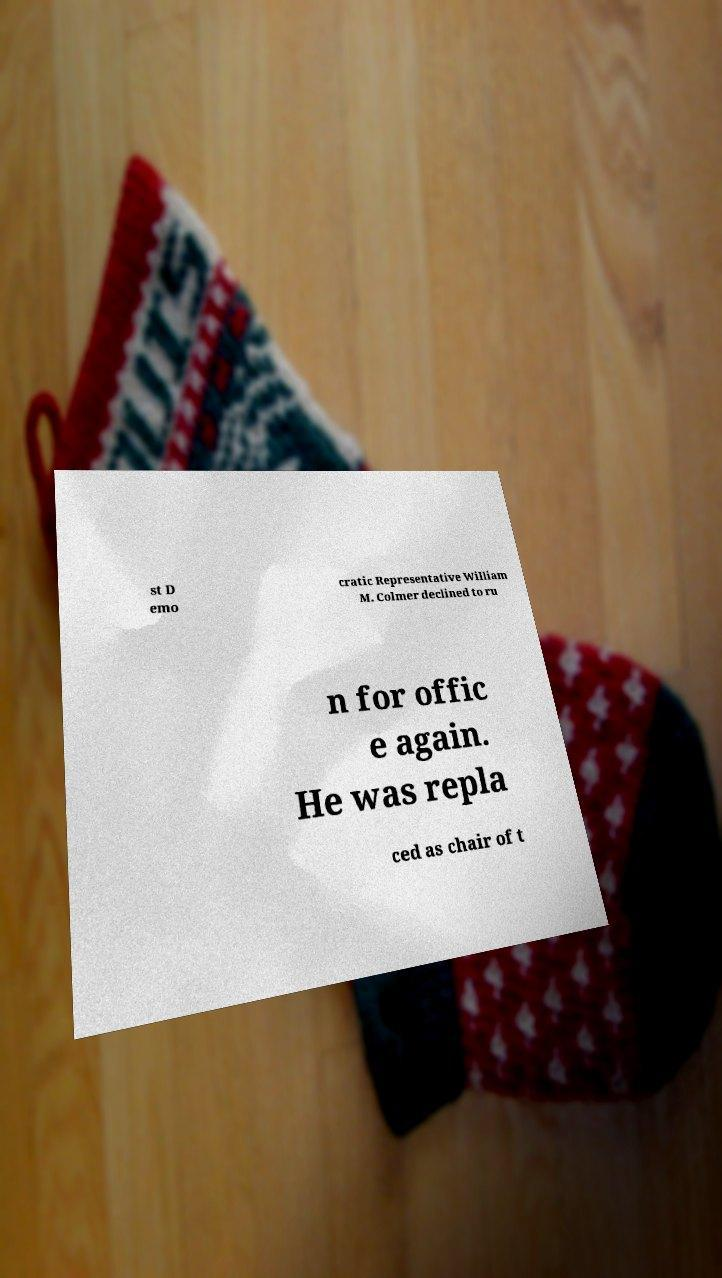Can you accurately transcribe the text from the provided image for me? st D emo cratic Representative William M. Colmer declined to ru n for offic e again. He was repla ced as chair of t 